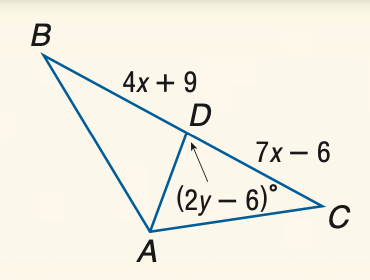Answer the mathemtical geometry problem and directly provide the correct option letter.
Question: Find x if A D is a median of \triangle A B C.
Choices: A: 3 B: 5 C: 10 D: 15 B 